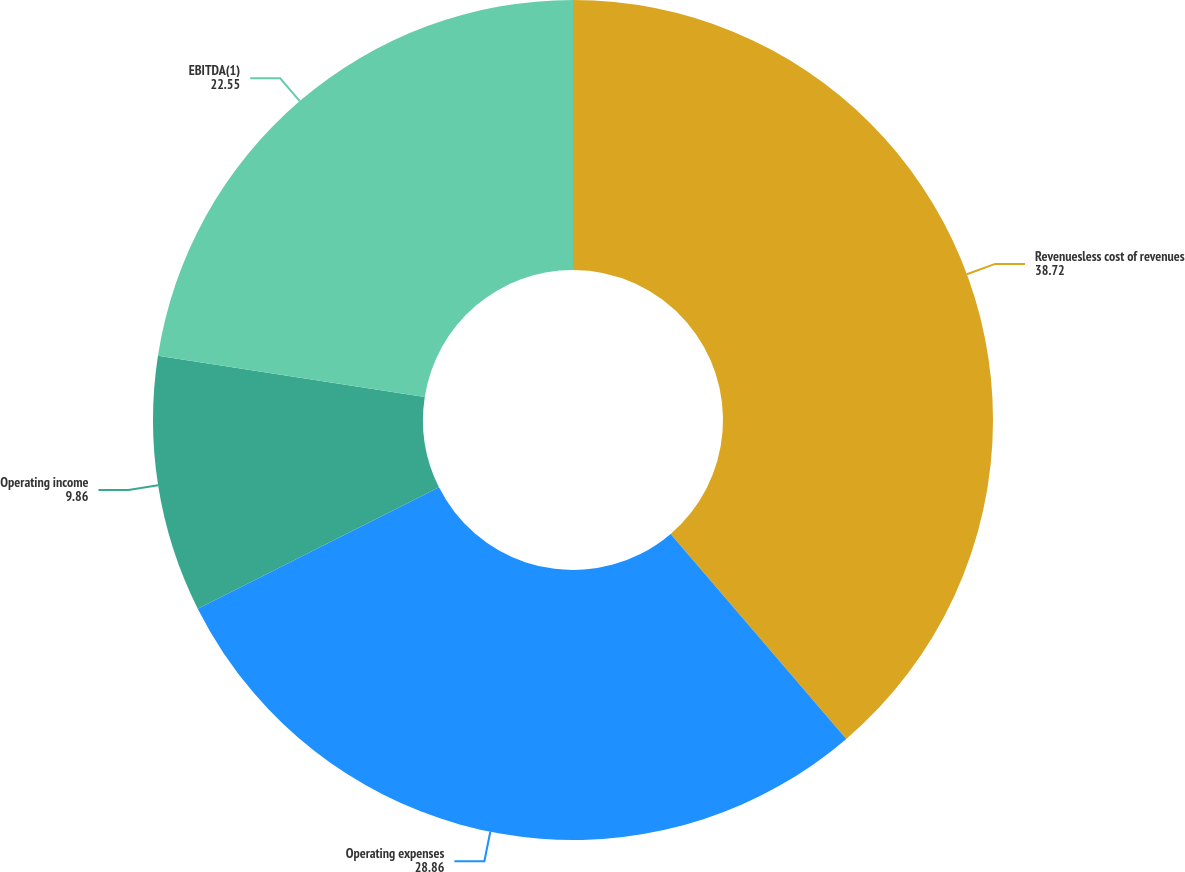Convert chart. <chart><loc_0><loc_0><loc_500><loc_500><pie_chart><fcel>Revenuesless cost of revenues<fcel>Operating expenses<fcel>Operating income<fcel>EBITDA(1)<nl><fcel>38.72%<fcel>28.86%<fcel>9.86%<fcel>22.55%<nl></chart> 